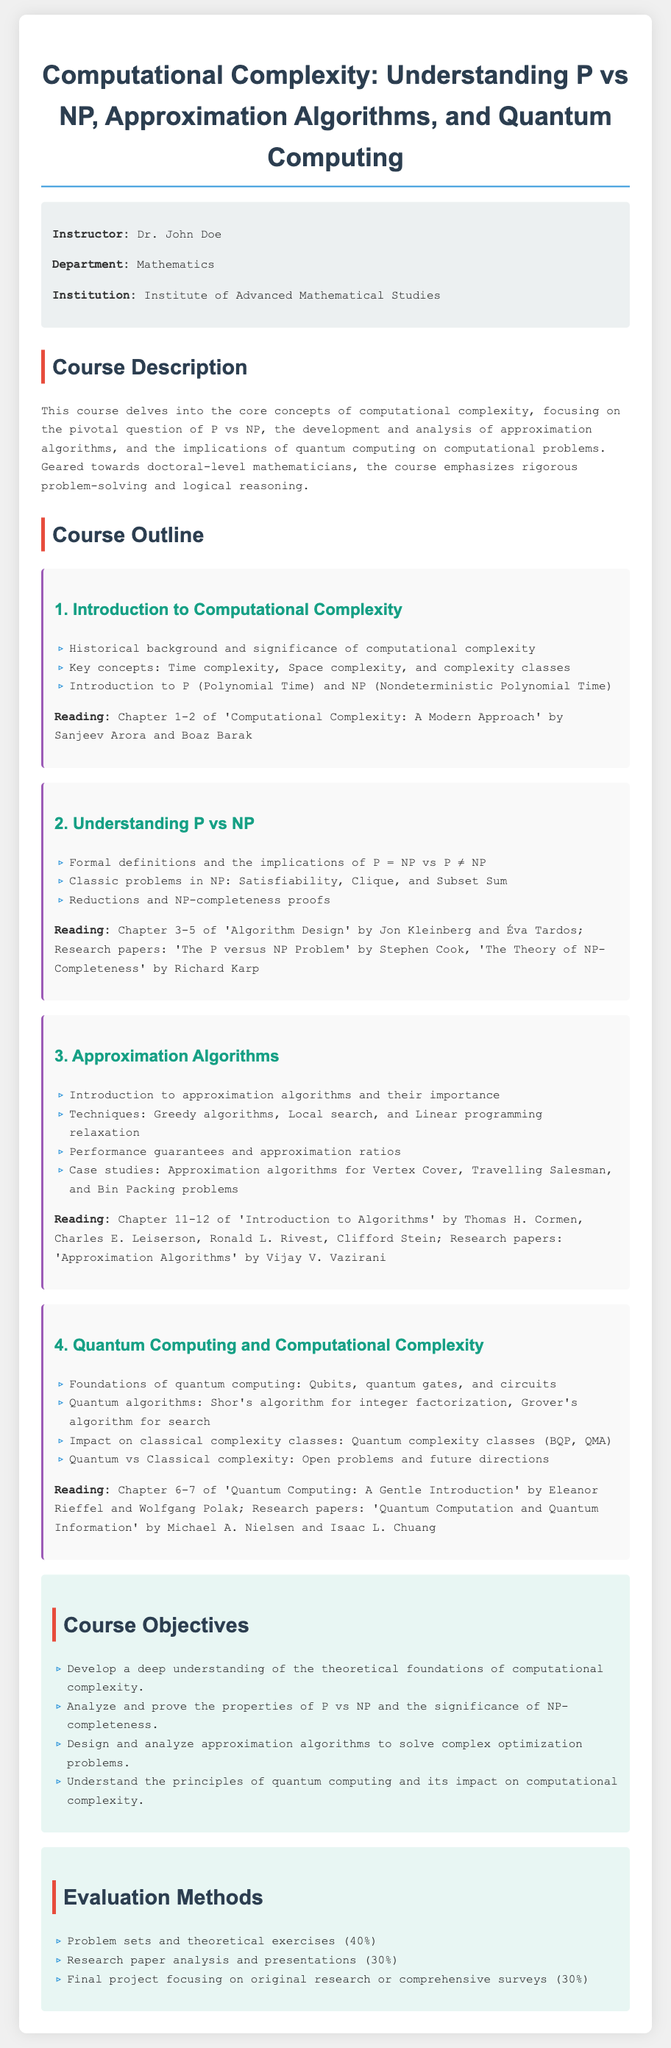What is the name of the instructor? The instructor's name is provided in the document under instructor info.
Answer: Dr. John Doe What is the course's focus? The course's focus is outlined in the course description section of the document.
Answer: Computational complexity What percentage of the evaluation is based on problem sets? The evaluation methods section specifies the percentage allocated for problem sets.
Answer: 40% Which chapter discusses the introduction to computational complexity? The reading section of the first module indicates which chapters are relevant to this topic.
Answer: Chapter 1-2 What is one classic problem in NP mentioned in the syllabus? The second module lists classic problems in NP that are discussed in detail.
Answer: Satisfiability What is the primary objective related to approximation algorithms? The course objectives section describes the aim regarding approximation algorithms.
Answer: Design and analyze approximation algorithms What is one of the quantum algorithms covered in the course? The fourth module provides information about specific quantum algorithms that will be taught.
Answer: Shor's algorithm Which research paper is associated with the P vs NP problem? The reading for the second module includes this specific research paper related to the P vs NP discussion.
Answer: The P versus NP Problem by Stephen Cook What is the total percentage of the final project evaluation? The evaluation methods list the weight of the final project.
Answer: 30% 